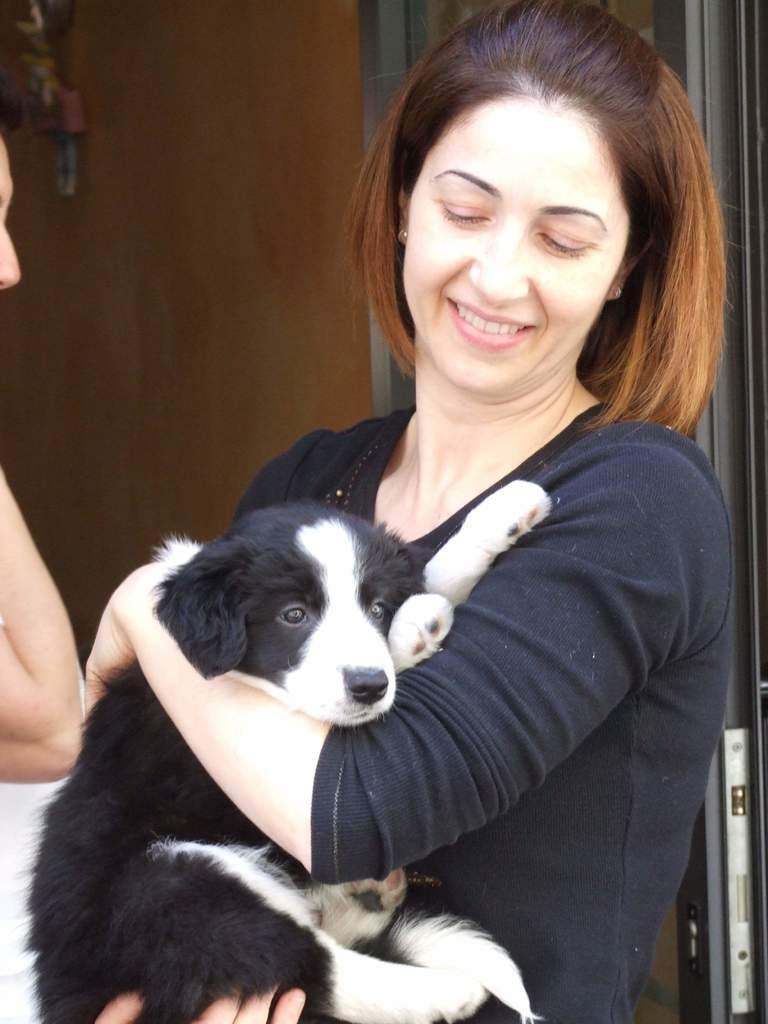How many people are present in the image? There are two people in the image. What is one person doing with an animal in the image? One person is holding a dog in the image. What is the color pattern of the dog? The dog is black and white in color. What is the color of the background in the image? The background of the image is brown. What type of secretary can be seen working in the image? There is no secretary present in the image; it features two people and a dog. What role does the actor play in the image? There is no actor present in the image; it features two people and a dog. 